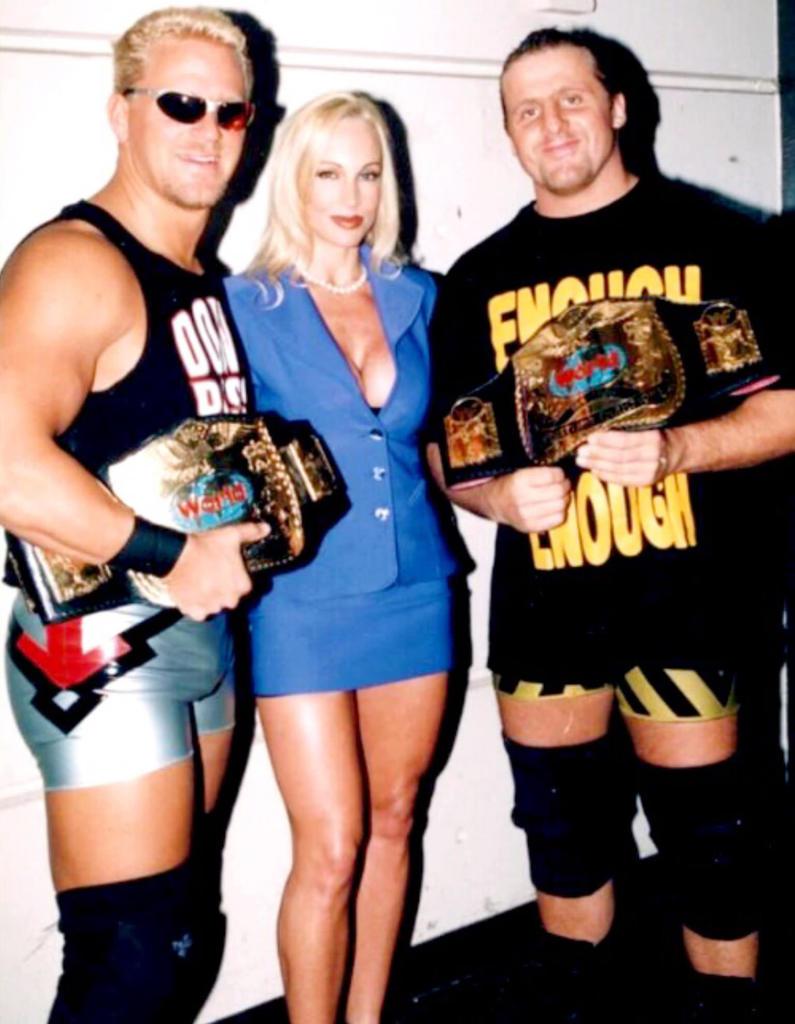What is the words on the man's shirt on the right?
Your response must be concise. Enough. 